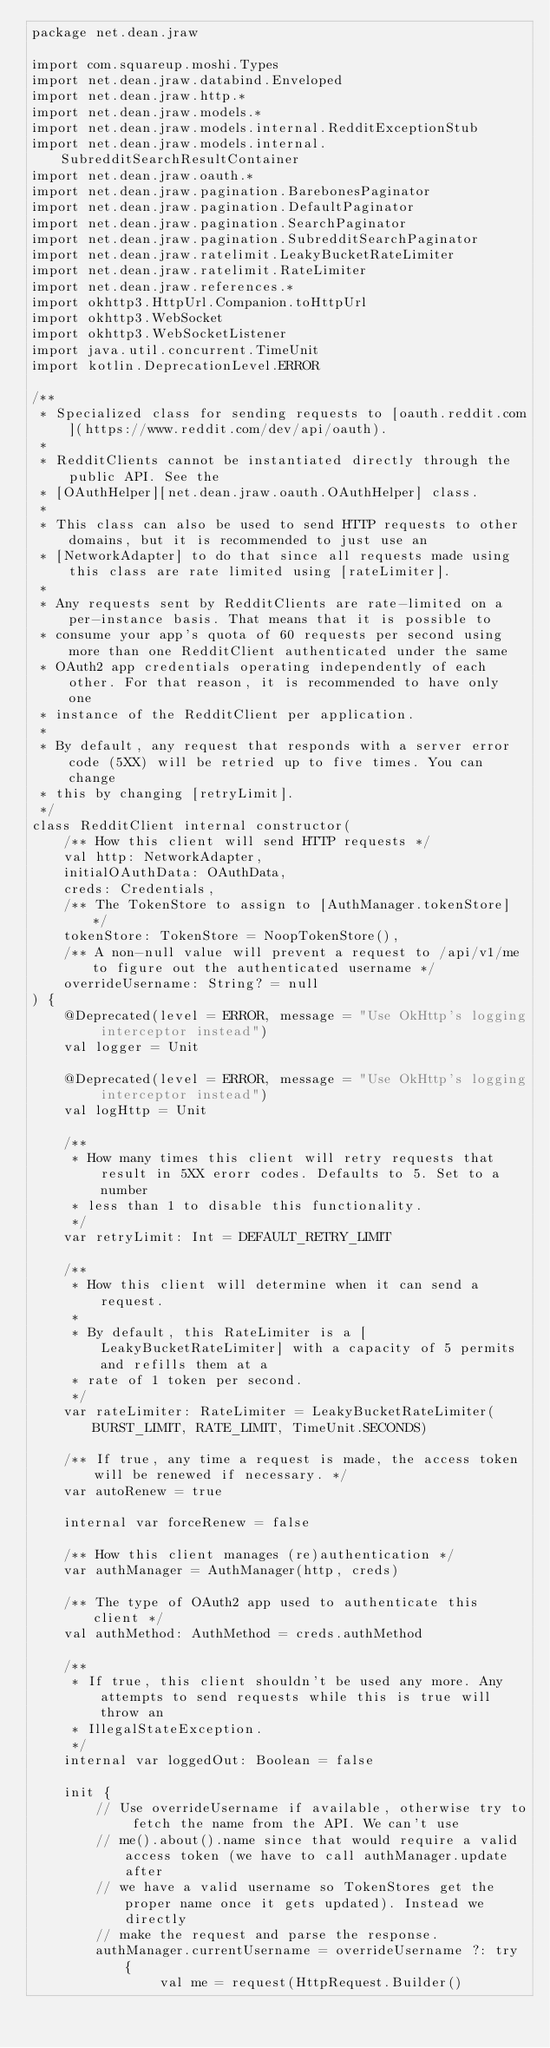Convert code to text. <code><loc_0><loc_0><loc_500><loc_500><_Kotlin_>package net.dean.jraw

import com.squareup.moshi.Types
import net.dean.jraw.databind.Enveloped
import net.dean.jraw.http.*
import net.dean.jraw.models.*
import net.dean.jraw.models.internal.RedditExceptionStub
import net.dean.jraw.models.internal.SubredditSearchResultContainer
import net.dean.jraw.oauth.*
import net.dean.jraw.pagination.BarebonesPaginator
import net.dean.jraw.pagination.DefaultPaginator
import net.dean.jraw.pagination.SearchPaginator
import net.dean.jraw.pagination.SubredditSearchPaginator
import net.dean.jraw.ratelimit.LeakyBucketRateLimiter
import net.dean.jraw.ratelimit.RateLimiter
import net.dean.jraw.references.*
import okhttp3.HttpUrl.Companion.toHttpUrl
import okhttp3.WebSocket
import okhttp3.WebSocketListener
import java.util.concurrent.TimeUnit
import kotlin.DeprecationLevel.ERROR

/**
 * Specialized class for sending requests to [oauth.reddit.com](https://www.reddit.com/dev/api/oauth).
 *
 * RedditClients cannot be instantiated directly through the public API. See the
 * [OAuthHelper][net.dean.jraw.oauth.OAuthHelper] class.
 *
 * This class can also be used to send HTTP requests to other domains, but it is recommended to just use an
 * [NetworkAdapter] to do that since all requests made using this class are rate limited using [rateLimiter].
 *
 * Any requests sent by RedditClients are rate-limited on a per-instance basis. That means that it is possible to
 * consume your app's quota of 60 requests per second using more than one RedditClient authenticated under the same
 * OAuth2 app credentials operating independently of each other. For that reason, it is recommended to have only one
 * instance of the RedditClient per application.
 *
 * By default, any request that responds with a server error code (5XX) will be retried up to five times. You can change
 * this by changing [retryLimit].
 */
class RedditClient internal constructor(
    /** How this client will send HTTP requests */
    val http: NetworkAdapter,
    initialOAuthData: OAuthData,
    creds: Credentials,
    /** The TokenStore to assign to [AuthManager.tokenStore] */
    tokenStore: TokenStore = NoopTokenStore(),
    /** A non-null value will prevent a request to /api/v1/me to figure out the authenticated username */
    overrideUsername: String? = null
) {
    @Deprecated(level = ERROR, message = "Use OkHttp's logging interceptor instead")
    val logger = Unit

    @Deprecated(level = ERROR, message = "Use OkHttp's logging interceptor instead")
    val logHttp = Unit

    /**
     * How many times this client will retry requests that result in 5XX erorr codes. Defaults to 5. Set to a number
     * less than 1 to disable this functionality.
     */
    var retryLimit: Int = DEFAULT_RETRY_LIMIT

    /**
     * How this client will determine when it can send a request.
     *
     * By default, this RateLimiter is a [LeakyBucketRateLimiter] with a capacity of 5 permits and refills them at a
     * rate of 1 token per second.
     */
    var rateLimiter: RateLimiter = LeakyBucketRateLimiter(BURST_LIMIT, RATE_LIMIT, TimeUnit.SECONDS)

    /** If true, any time a request is made, the access token will be renewed if necessary. */
    var autoRenew = true

    internal var forceRenew = false

    /** How this client manages (re)authentication */
    var authManager = AuthManager(http, creds)

    /** The type of OAuth2 app used to authenticate this client */
    val authMethod: AuthMethod = creds.authMethod

    /**
     * If true, this client shouldn't be used any more. Any attempts to send requests while this is true will throw an
     * IllegalStateException.
     */
    internal var loggedOut: Boolean = false

    init {
        // Use overrideUsername if available, otherwise try to fetch the name from the API. We can't use
        // me().about().name since that would require a valid access token (we have to call authManager.update after
        // we have a valid username so TokenStores get the proper name once it gets updated). Instead we directly
        // make the request and parse the response.
        authManager.currentUsername = overrideUsername ?: try {
                val me = request(HttpRequest.Builder()</code> 